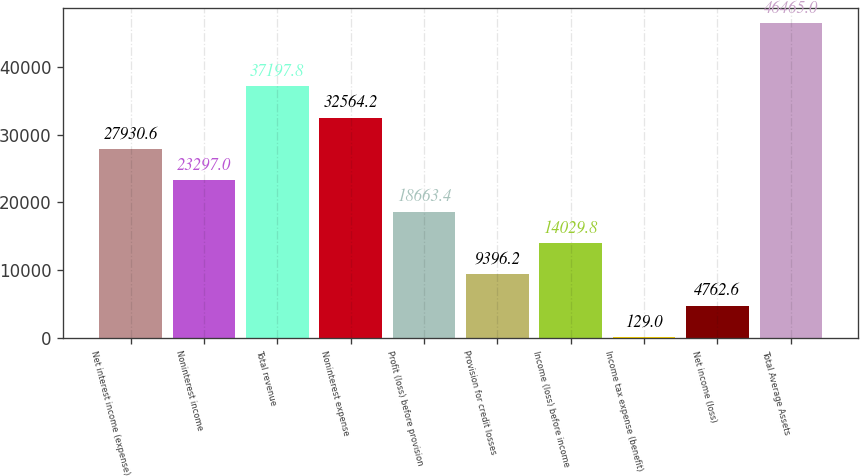<chart> <loc_0><loc_0><loc_500><loc_500><bar_chart><fcel>Net interest income (expense)<fcel>Noninterest income<fcel>Total revenue<fcel>Noninterest expense<fcel>Profit (loss) before provision<fcel>Provision for credit losses<fcel>Income (loss) before income<fcel>Income tax expense (benefit)<fcel>Net income (loss)<fcel>Total Average Assets<nl><fcel>27930.6<fcel>23297<fcel>37197.8<fcel>32564.2<fcel>18663.4<fcel>9396.2<fcel>14029.8<fcel>129<fcel>4762.6<fcel>46465<nl></chart> 